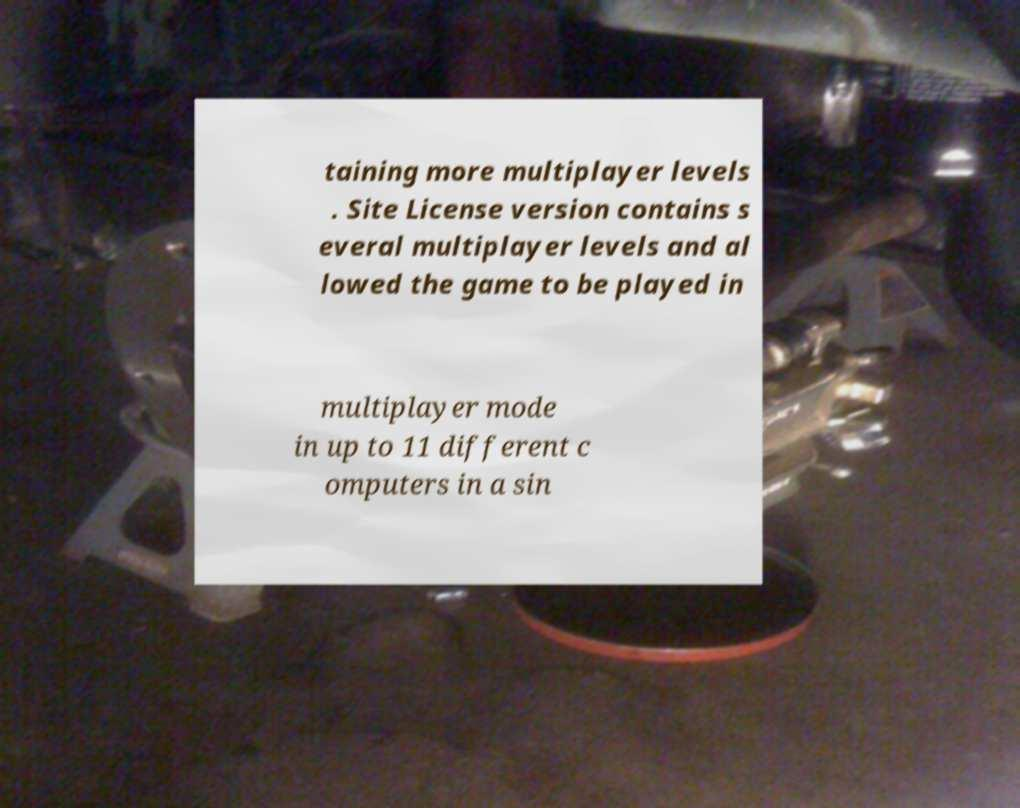Can you accurately transcribe the text from the provided image for me? taining more multiplayer levels . Site License version contains s everal multiplayer levels and al lowed the game to be played in multiplayer mode in up to 11 different c omputers in a sin 